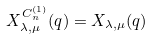Convert formula to latex. <formula><loc_0><loc_0><loc_500><loc_500>X _ { \lambda , \mu } ^ { C _ { n } ^ { ( 1 ) } } ( q ) = X _ { \lambda , \mu } ( q )</formula> 